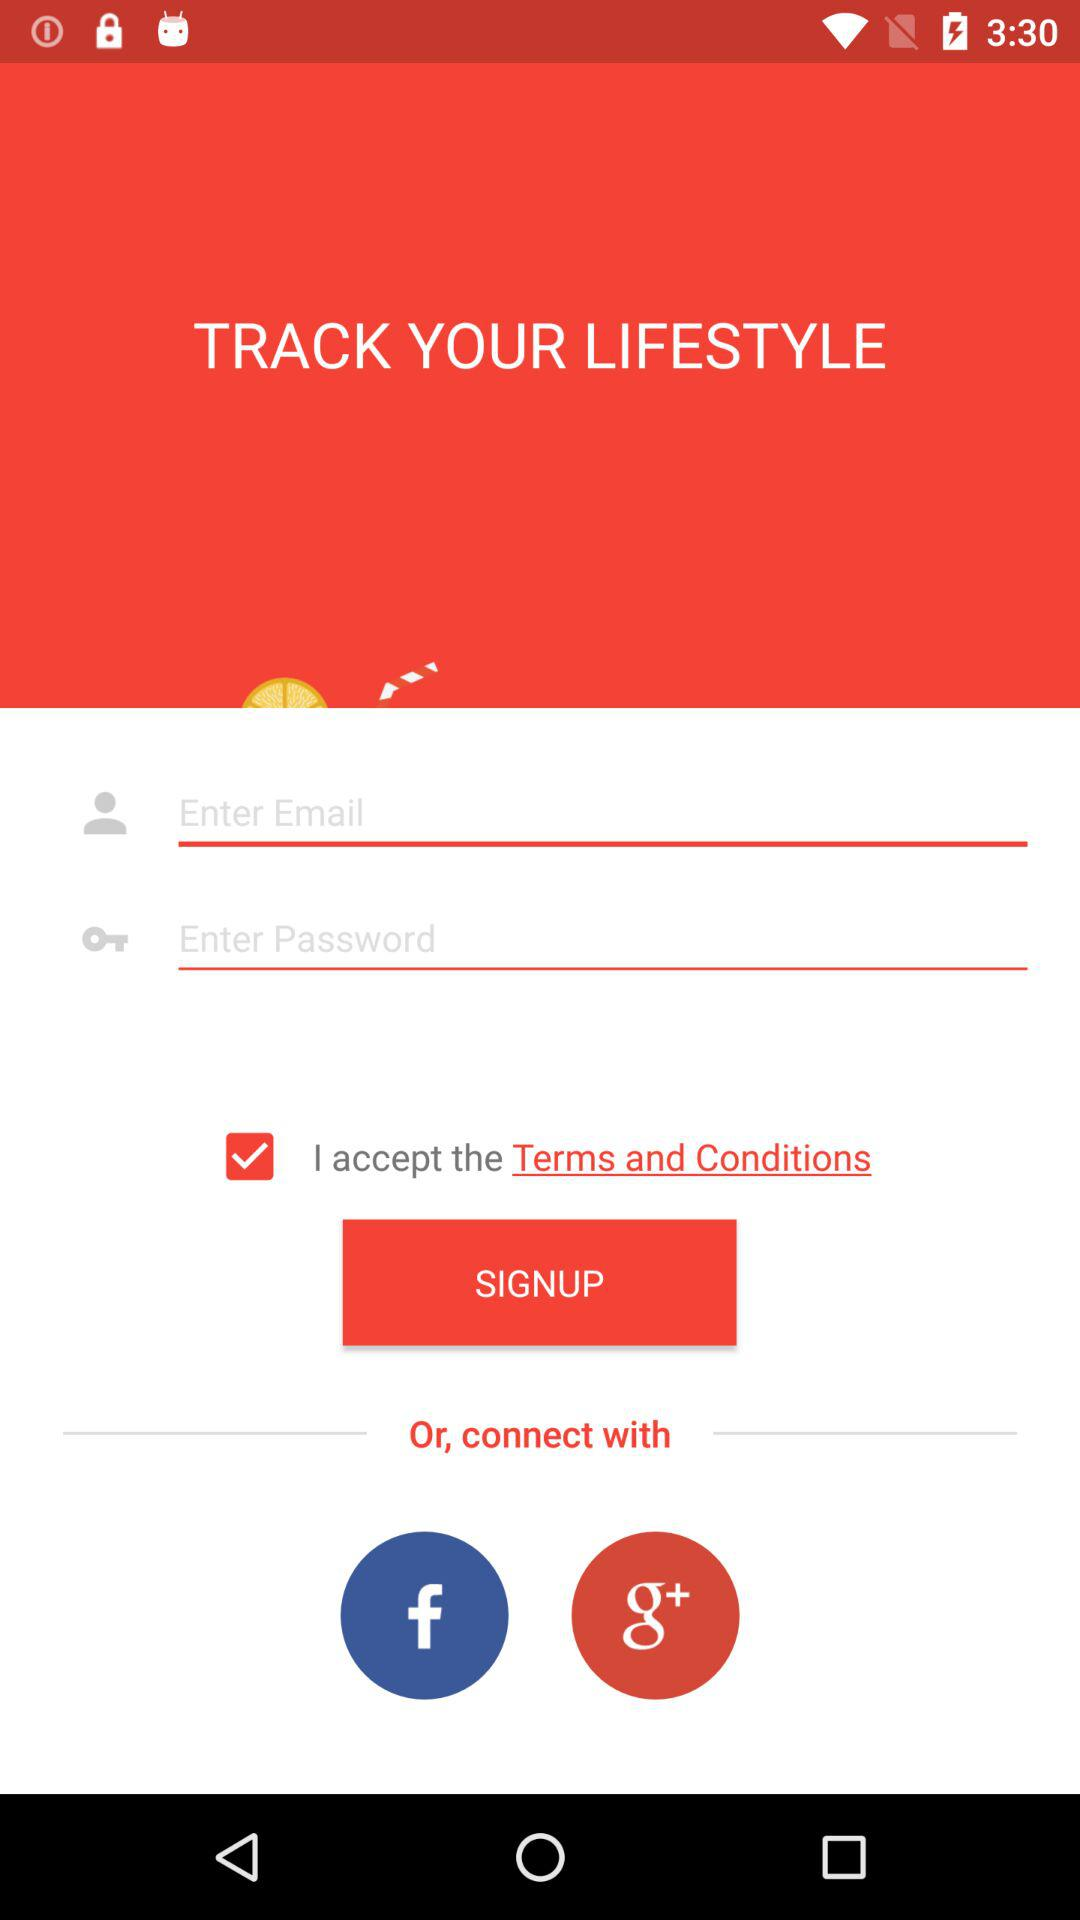What are the options for connecting? The options are "Email", "Facebook" and "Google+". 